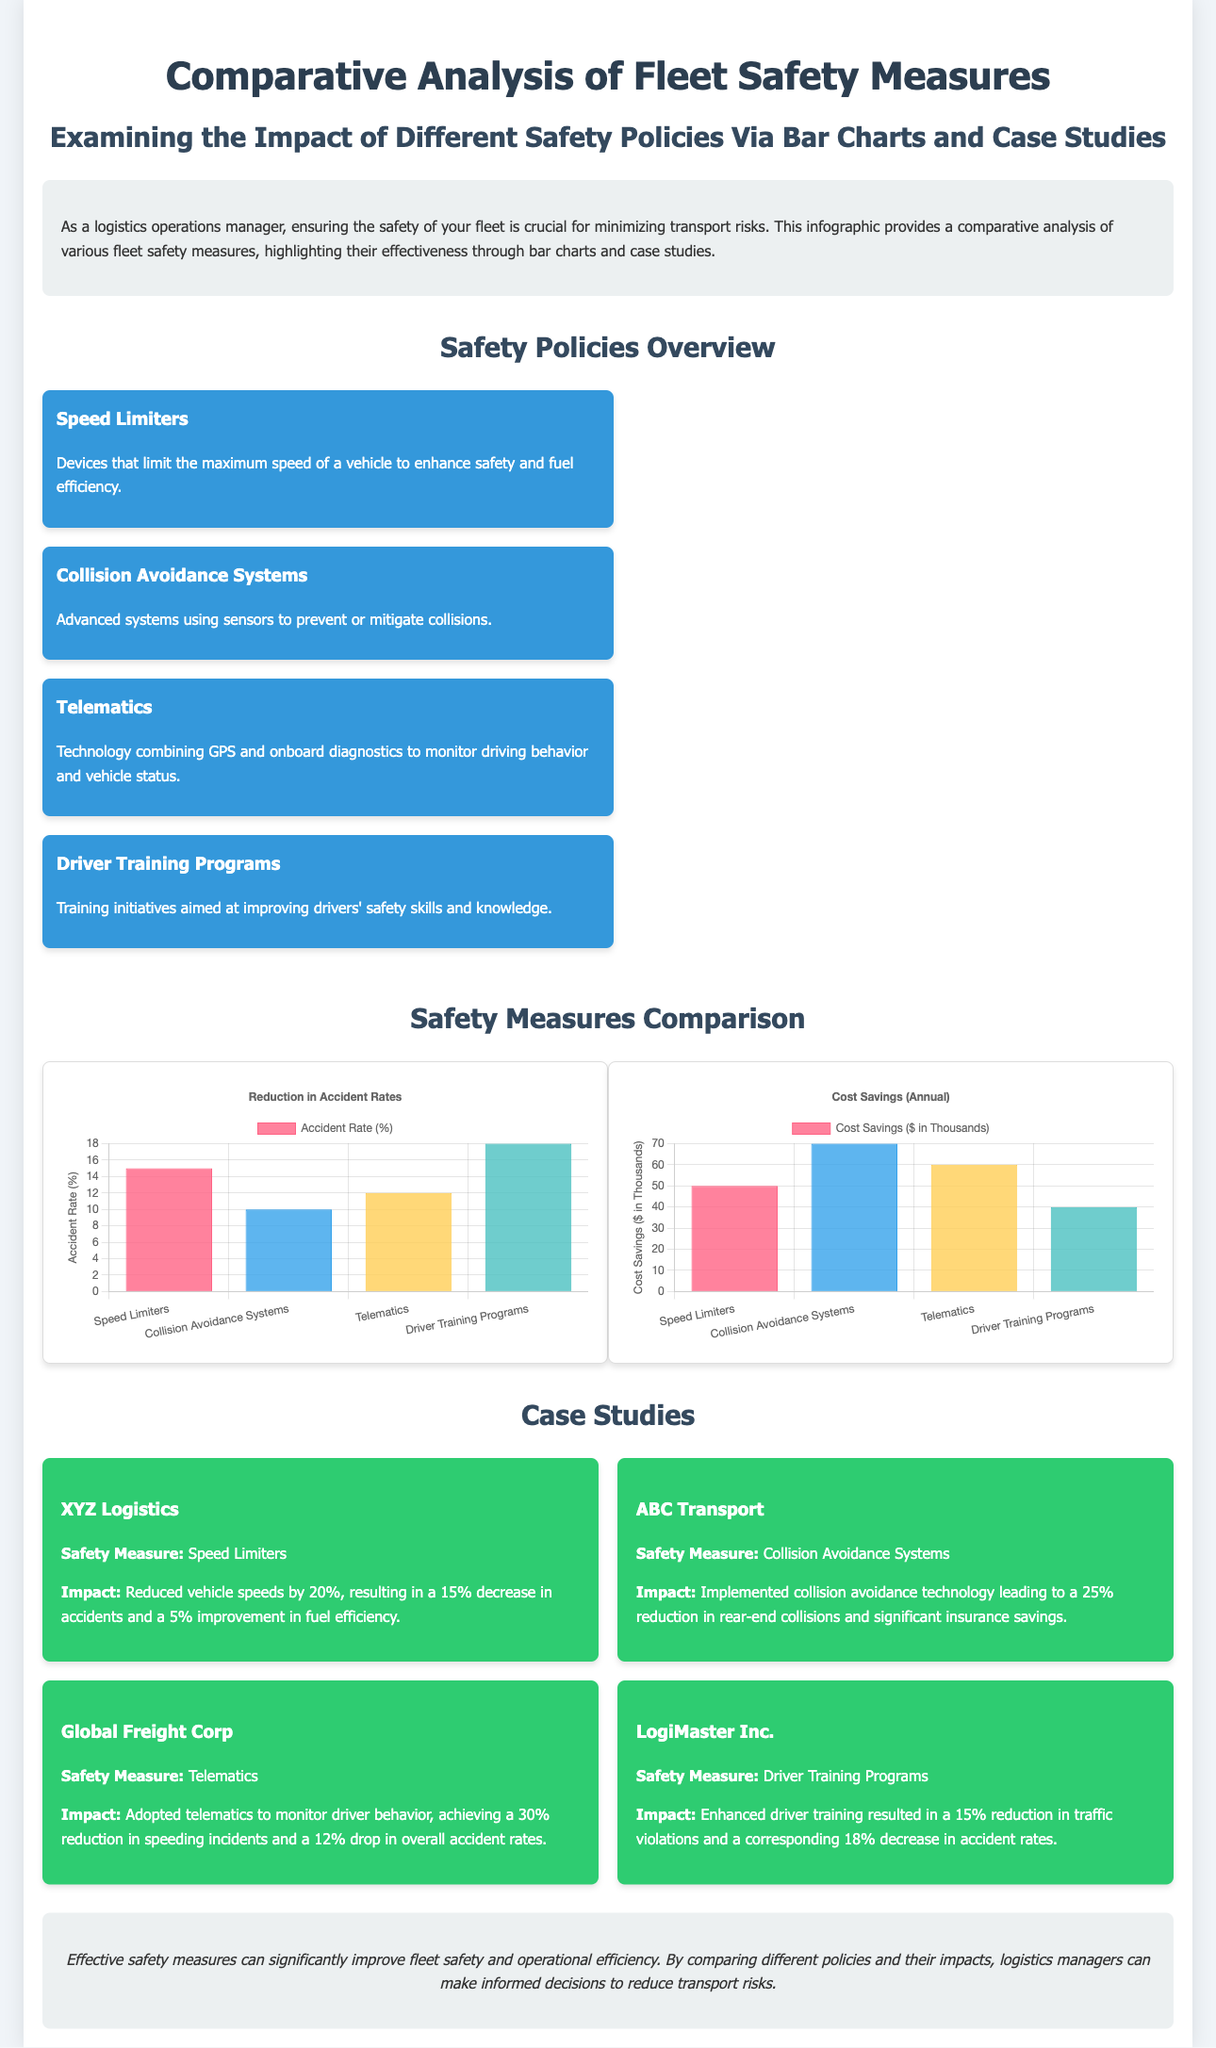What is the title of the infographic? The title of the infographic is provided in the header section of the document, which is "Comparative Analysis of Fleet Safety Measures".
Answer: Comparative Analysis of Fleet Safety Measures What safety measure resulted in a 25% reduction in rear-end collisions? This information is found in the case study of ABC Transport, which highlights the impact of collision avoidance systems.
Answer: Collision Avoidance Systems What was the accident rate reduction percentage for telematics? This statistic is located in the comparative accident rate chart in the document, which specifies the reduction for telematics.
Answer: 12 Which safety measure mentioned has the least cost savings? The cost savings chart indicates this measure as the one with the lowest bar compared to others, specifically for driver training programs.
Answer: Driver Training Programs How many case studies are presented in the infographic? The number of case studies can be counted in the relevant section of the document, which lists four companies.
Answer: 4 